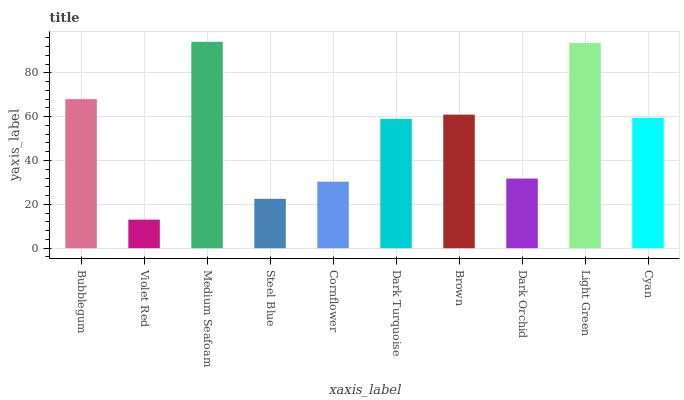Is Violet Red the minimum?
Answer yes or no. Yes. Is Medium Seafoam the maximum?
Answer yes or no. Yes. Is Medium Seafoam the minimum?
Answer yes or no. No. Is Violet Red the maximum?
Answer yes or no. No. Is Medium Seafoam greater than Violet Red?
Answer yes or no. Yes. Is Violet Red less than Medium Seafoam?
Answer yes or no. Yes. Is Violet Red greater than Medium Seafoam?
Answer yes or no. No. Is Medium Seafoam less than Violet Red?
Answer yes or no. No. Is Cyan the high median?
Answer yes or no. Yes. Is Dark Turquoise the low median?
Answer yes or no. Yes. Is Bubblegum the high median?
Answer yes or no. No. Is Dark Orchid the low median?
Answer yes or no. No. 